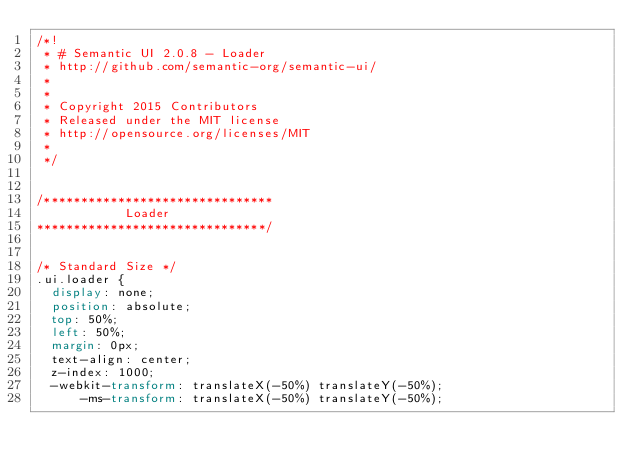Convert code to text. <code><loc_0><loc_0><loc_500><loc_500><_CSS_>/*!
 * # Semantic UI 2.0.8 - Loader
 * http://github.com/semantic-org/semantic-ui/
 *
 *
 * Copyright 2015 Contributors
 * Released under the MIT license
 * http://opensource.org/licenses/MIT
 *
 */


/*******************************
            Loader
*******************************/


/* Standard Size */
.ui.loader {
  display: none;
  position: absolute;
  top: 50%;
  left: 50%;
  margin: 0px;
  text-align: center;
  z-index: 1000;
  -webkit-transform: translateX(-50%) translateY(-50%);
      -ms-transform: translateX(-50%) translateY(-50%);</code> 